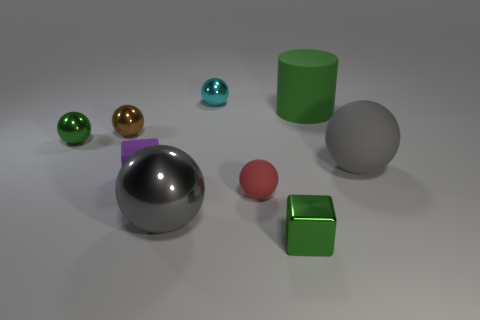What number of tiny purple matte things are left of the tiny green object to the right of the green metal sphere?
Give a very brief answer. 1. How many other things are there of the same shape as the small red matte object?
Provide a short and direct response. 5. There is a cylinder that is the same color as the tiny metallic block; what is it made of?
Provide a short and direct response. Rubber. How many other big objects have the same color as the large metallic object?
Provide a short and direct response. 1. The small sphere that is made of the same material as the big green thing is what color?
Ensure brevity in your answer.  Red. Is there a cyan object that has the same size as the brown metal object?
Keep it short and to the point. Yes. Are there more cyan balls that are behind the large green matte cylinder than gray objects left of the gray rubber sphere?
Your answer should be compact. No. Is the big object to the left of the tiny metallic block made of the same material as the tiny purple cube that is in front of the green sphere?
Provide a succinct answer. No. What shape is the green rubber object that is the same size as the gray shiny thing?
Offer a very short reply. Cylinder. Are there any small objects of the same shape as the large green object?
Your answer should be very brief. No. 